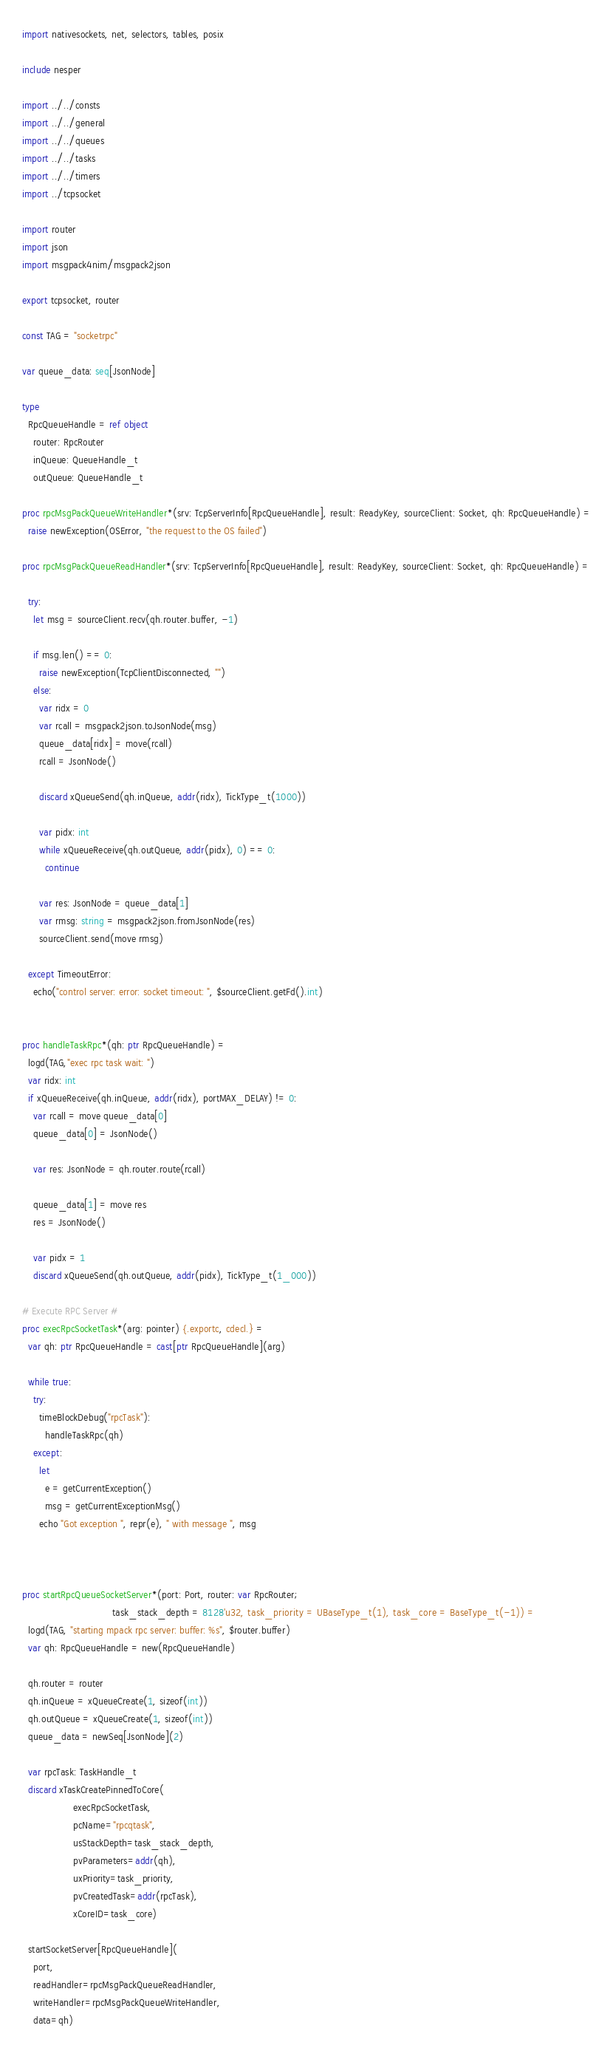<code> <loc_0><loc_0><loc_500><loc_500><_Nim_>import nativesockets, net, selectors, tables, posix

include nesper

import ../../consts
import ../../general
import ../../queues
import ../../tasks
import ../../timers
import ../tcpsocket

import router
import json
import msgpack4nim/msgpack2json

export tcpsocket, router

const TAG = "socketrpc"

var queue_data: seq[JsonNode]

type 
  RpcQueueHandle = ref object
    router: RpcRouter
    inQueue: QueueHandle_t
    outQueue: QueueHandle_t

proc rpcMsgPackQueueWriteHandler*(srv: TcpServerInfo[RpcQueueHandle], result: ReadyKey, sourceClient: Socket, qh: RpcQueueHandle) =
  raise newException(OSError, "the request to the OS failed")

proc rpcMsgPackQueueReadHandler*(srv: TcpServerInfo[RpcQueueHandle], result: ReadyKey, sourceClient: Socket, qh: RpcQueueHandle) =

  try:
    let msg = sourceClient.recv(qh.router.buffer, -1)

    if msg.len() == 0:
      raise newException(TcpClientDisconnected, "")
    else:
      var ridx = 0
      var rcall = msgpack2json.toJsonNode(msg)
      queue_data[ridx] = move(rcall)
      rcall = JsonNode()
      
      discard xQueueSend(qh.inQueue, addr(ridx), TickType_t(1000)) 

      var pidx: int
      while xQueueReceive(qh.outQueue, addr(pidx), 0) == 0: 
        continue

      var res: JsonNode = queue_data[1]
      var rmsg: string = msgpack2json.fromJsonNode(res)
      sourceClient.send(move rmsg)

  except TimeoutError:
    echo("control server: error: socket timeout: ", $sourceClient.getFd().int)


proc handleTaskRpc*(qh: ptr RpcQueueHandle) =
  logd(TAG,"exec rpc task wait: ")
  var ridx: int
  if xQueueReceive(qh.inQueue, addr(ridx), portMAX_DELAY) != 0: 
    var rcall = move queue_data[0]
    queue_data[0] = JsonNode()

    var res: JsonNode = qh.router.route(rcall)

    queue_data[1] = move res
    res = JsonNode()
    
    var pidx = 1
    discard xQueueSend(qh.outQueue, addr(pidx), TickType_t(1_000)) 

# Execute RPC Server #
proc execRpcSocketTask*(arg: pointer) {.exportc, cdecl.} =
  var qh: ptr RpcQueueHandle = cast[ptr RpcQueueHandle](arg)

  while true:
    try:
      timeBlockDebug("rpcTask"):
        handleTaskRpc(qh)
    except:
      let
        e = getCurrentException()
        msg = getCurrentExceptionMsg()
      echo "Got exception ", repr(e), " with message ", msg



proc startRpcQueueSocketServer*(port: Port, router: var RpcRouter;
                                task_stack_depth = 8128'u32, task_priority = UBaseType_t(1), task_core = BaseType_t(-1)) =
  logd(TAG, "starting mpack rpc server: buffer: %s", $router.buffer)
  var qh: RpcQueueHandle = new(RpcQueueHandle)

  qh.router = router
  qh.inQueue = xQueueCreate(1, sizeof(int))
  qh.outQueue = xQueueCreate(1, sizeof(int))
  queue_data = newSeq[JsonNode](2)

  var rpcTask: TaskHandle_t
  discard xTaskCreatePinnedToCore(
                  execRpcSocketTask,
                  pcName="rpcqtask",
                  usStackDepth=task_stack_depth,
                  pvParameters=addr(qh),
                  uxPriority=task_priority,
                  pvCreatedTask=addr(rpcTask),
                  xCoreID=task_core)

  startSocketServer[RpcQueueHandle](
    port,
    readHandler=rpcMsgPackQueueReadHandler,
    writeHandler=rpcMsgPackQueueWriteHandler,
    data=qh)

</code> 